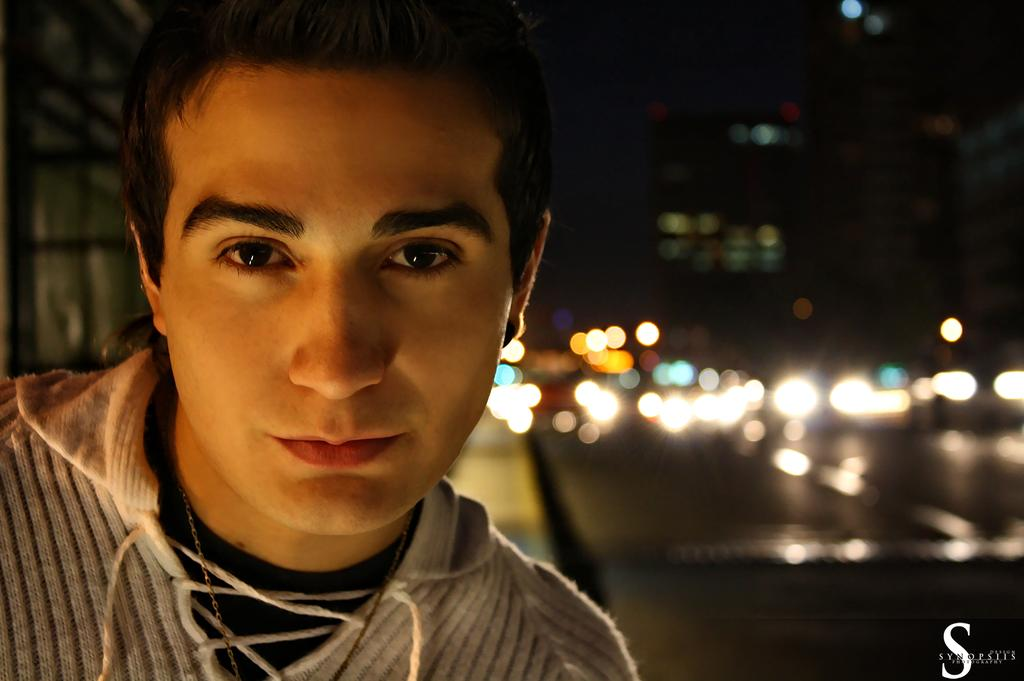What is the person in the image wearing? The person in the image is wearing a white and black color dress. What can be seen in the image besides the person? There are many lights visible in the image. Can you describe the background of the image? The background of the image is blurred. How many eggs are being used to make the pickle in the image? There is no mention of eggs or pickles in the image; it only features a person wearing a white and black color dress and many lights. 